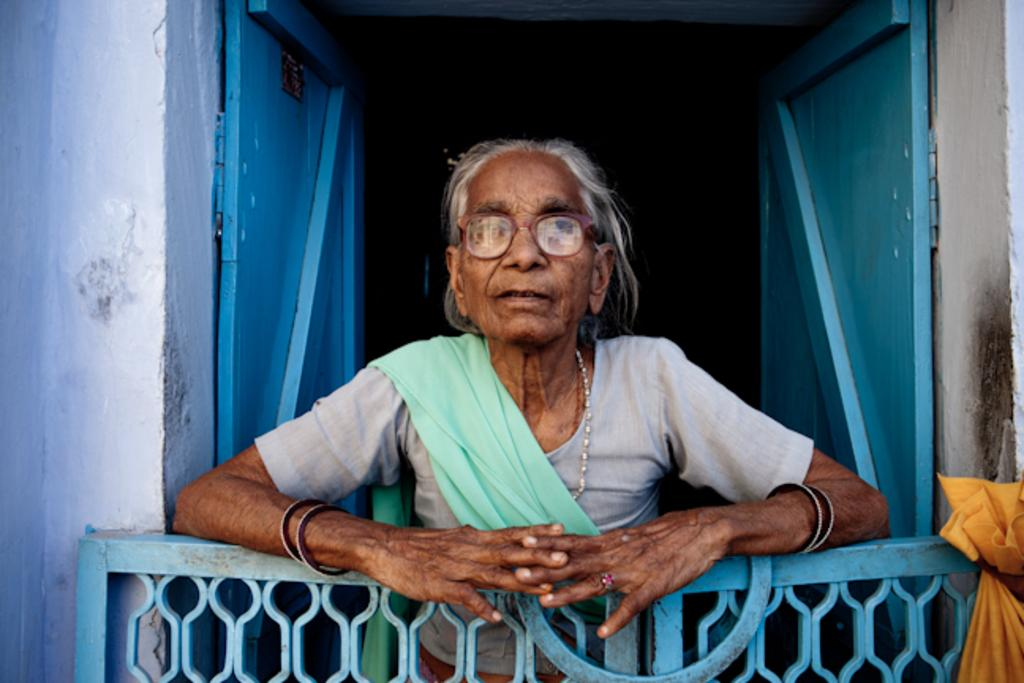What is the main subject in the center of the image? There is a person standing in the center of the image. What can be seen at the bottom of the image? There is a gate and a piece of cloth at the bottom of the image. What is visible in the background of the image? There is a wall and a door in the background of the image. What type of duck can be seen swimming in the water near the person in the image? There is no duck or water present in the image; it only features a person, a gate, a piece of cloth, a wall, and a door. 